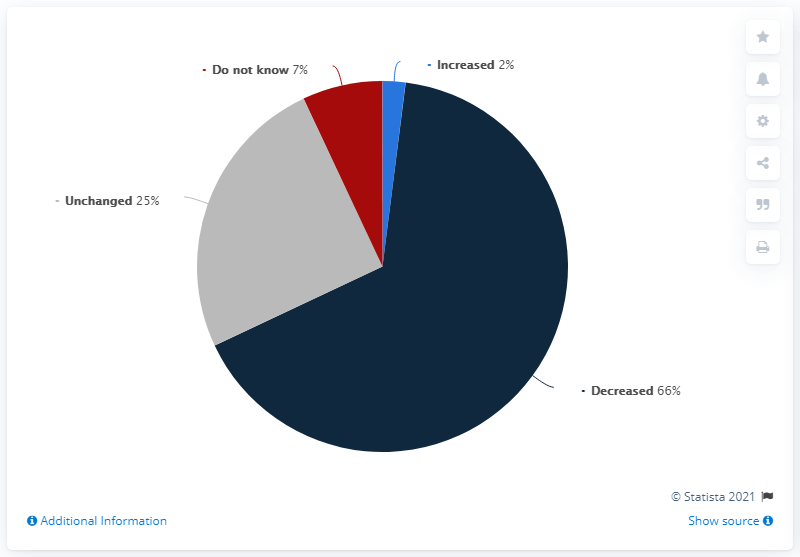Outline some significant characteristics in this image. Light blue indicates increased levels. Out of the total number of people, 91 remain unchanged or have decreased. 